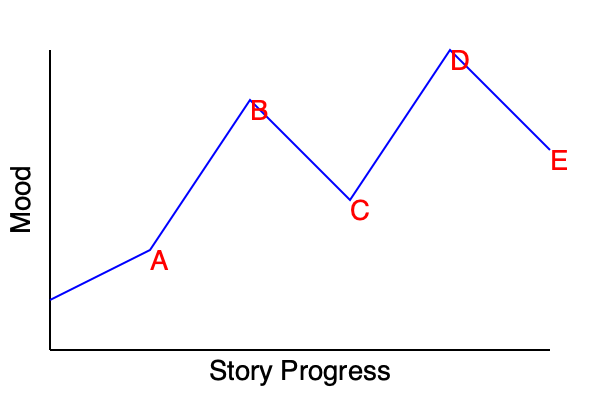Analyze the emotional journey of the protagonist in F. Scott Fitzgerald's "The Great Gatsby" using the provided line graph. Identify the key events (A-E) that correspond to significant mood changes, and explain how these fluctuations reflect Jay Gatsby's character development throughout the novel. To analyze the emotional journey of Jay Gatsby using the line graph, we need to consider the major events in the novel and how they affect his mood:

1. Starting point: The graph begins at a moderate level, representing Gatsby's initial state of hopeful anticipation.

2. Point A: A slight dip in mood, possibly representing Gatsby's first encounter with Daisy after many years, where he feels nervous and uncertain.

3. Point B: A significant peak in mood, likely corresponding to Gatsby and Daisy's reunion and rekindling of their relationship. This represents Gatsby's highest emotional point in the story.

4. Point C: A notable drop in mood, which could represent the confrontation between Gatsby, Tom, and Daisy in the hotel room. This event challenges Gatsby's idealized vision of his relationship with Daisy.

5. Point D: The lowest point on the graph, likely representing the aftermath of Myrtle's death and Gatsby's realization that his dream is slipping away. This is the moment of greatest despair for Gatsby.

6. Point E: A slight upturn at the end, which might represent Gatsby's final moments of hope before his death, still waiting for Daisy's call.

These mood changes reflect Gatsby's character development by showing:

1. His initial optimism and belief in the American Dream.
2. The euphoria of reconnecting with Daisy and believing his dream is within reach.
3. The harsh reality check when confronted with the complexities of real relationships and societal expectations.
4. His despair when facing the consequences of his actions and the unraveling of his carefully constructed world.
5. His unwavering hope, even in the face of tragedy, which ultimately leads to his downfall.

This emotional journey highlights Gatsby's idealism, his obsession with the past, and his inability to fully grasp the reality of his situation, all of which are central to his character in the novel.
Answer: The graph depicts Gatsby's emotional journey from hopeful anticipation to euphoria, then through disillusionment and despair, ending with a final moment of misplaced hope, reflecting his idealistic character and tragic fate. 